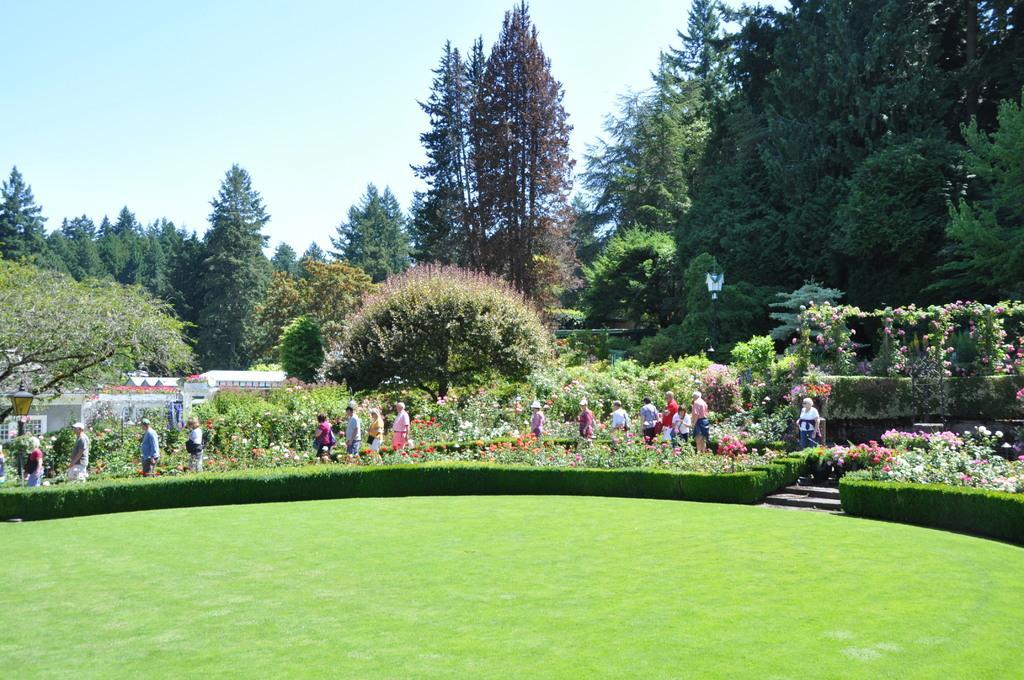Please provide a concise description of this image. In this picture we can see group of persons who are standing near to the plants and flowers. On the bottom we can see green grass. Here we can see stars near to the grass. In the background we can see many trees, street light and building. On the top there is a sky. 